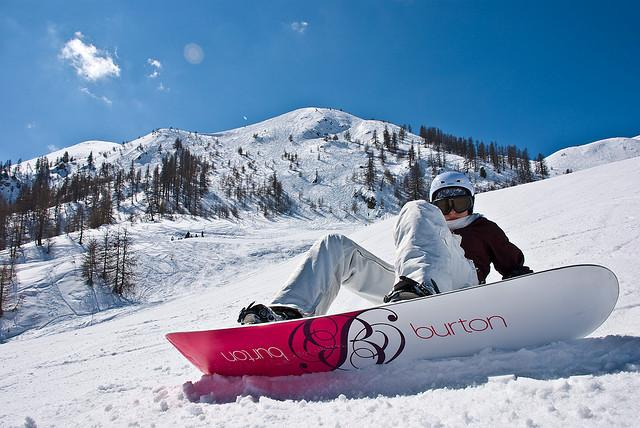Who crafted the thing on the person's feet? burton 